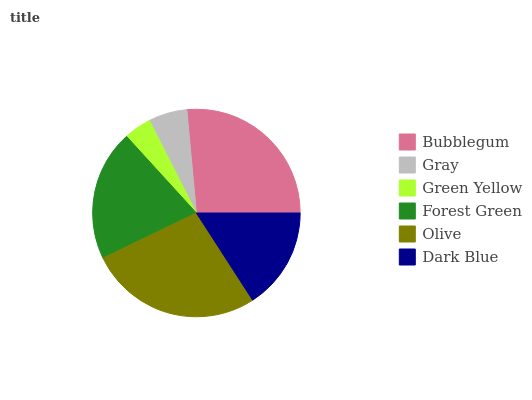Is Green Yellow the minimum?
Answer yes or no. Yes. Is Olive the maximum?
Answer yes or no. Yes. Is Gray the minimum?
Answer yes or no. No. Is Gray the maximum?
Answer yes or no. No. Is Bubblegum greater than Gray?
Answer yes or no. Yes. Is Gray less than Bubblegum?
Answer yes or no. Yes. Is Gray greater than Bubblegum?
Answer yes or no. No. Is Bubblegum less than Gray?
Answer yes or no. No. Is Forest Green the high median?
Answer yes or no. Yes. Is Dark Blue the low median?
Answer yes or no. Yes. Is Olive the high median?
Answer yes or no. No. Is Gray the low median?
Answer yes or no. No. 